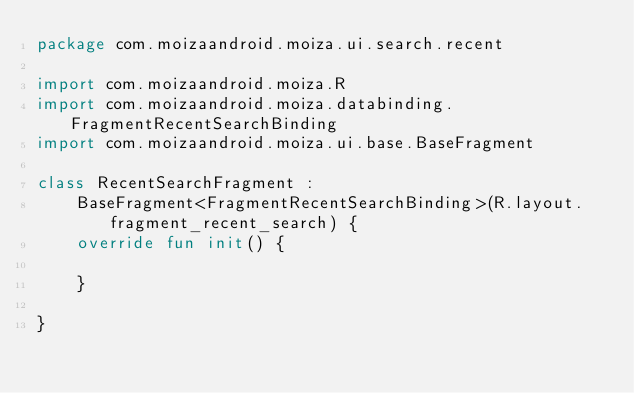Convert code to text. <code><loc_0><loc_0><loc_500><loc_500><_Kotlin_>package com.moizaandroid.moiza.ui.search.recent

import com.moizaandroid.moiza.R
import com.moizaandroid.moiza.databinding.FragmentRecentSearchBinding
import com.moizaandroid.moiza.ui.base.BaseFragment

class RecentSearchFragment :
    BaseFragment<FragmentRecentSearchBinding>(R.layout.fragment_recent_search) {
    override fun init() {

    }

}</code> 